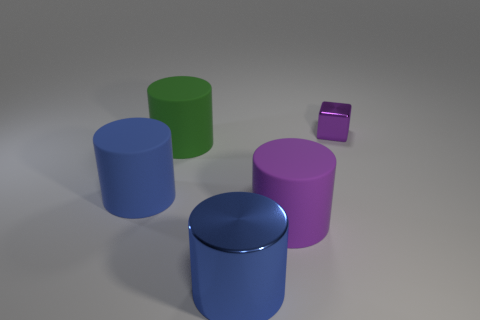Which object in the image seems closest to us? The cyan cylinder appears to be the closest to our viewpoint. How do the objects' colors interact with the lighting of the scene? The objects exhibit soft shadows and subtle reflections, indicating a diffuse light source that enhances their colors, making them appear vibrant yet true to their expected shades. 